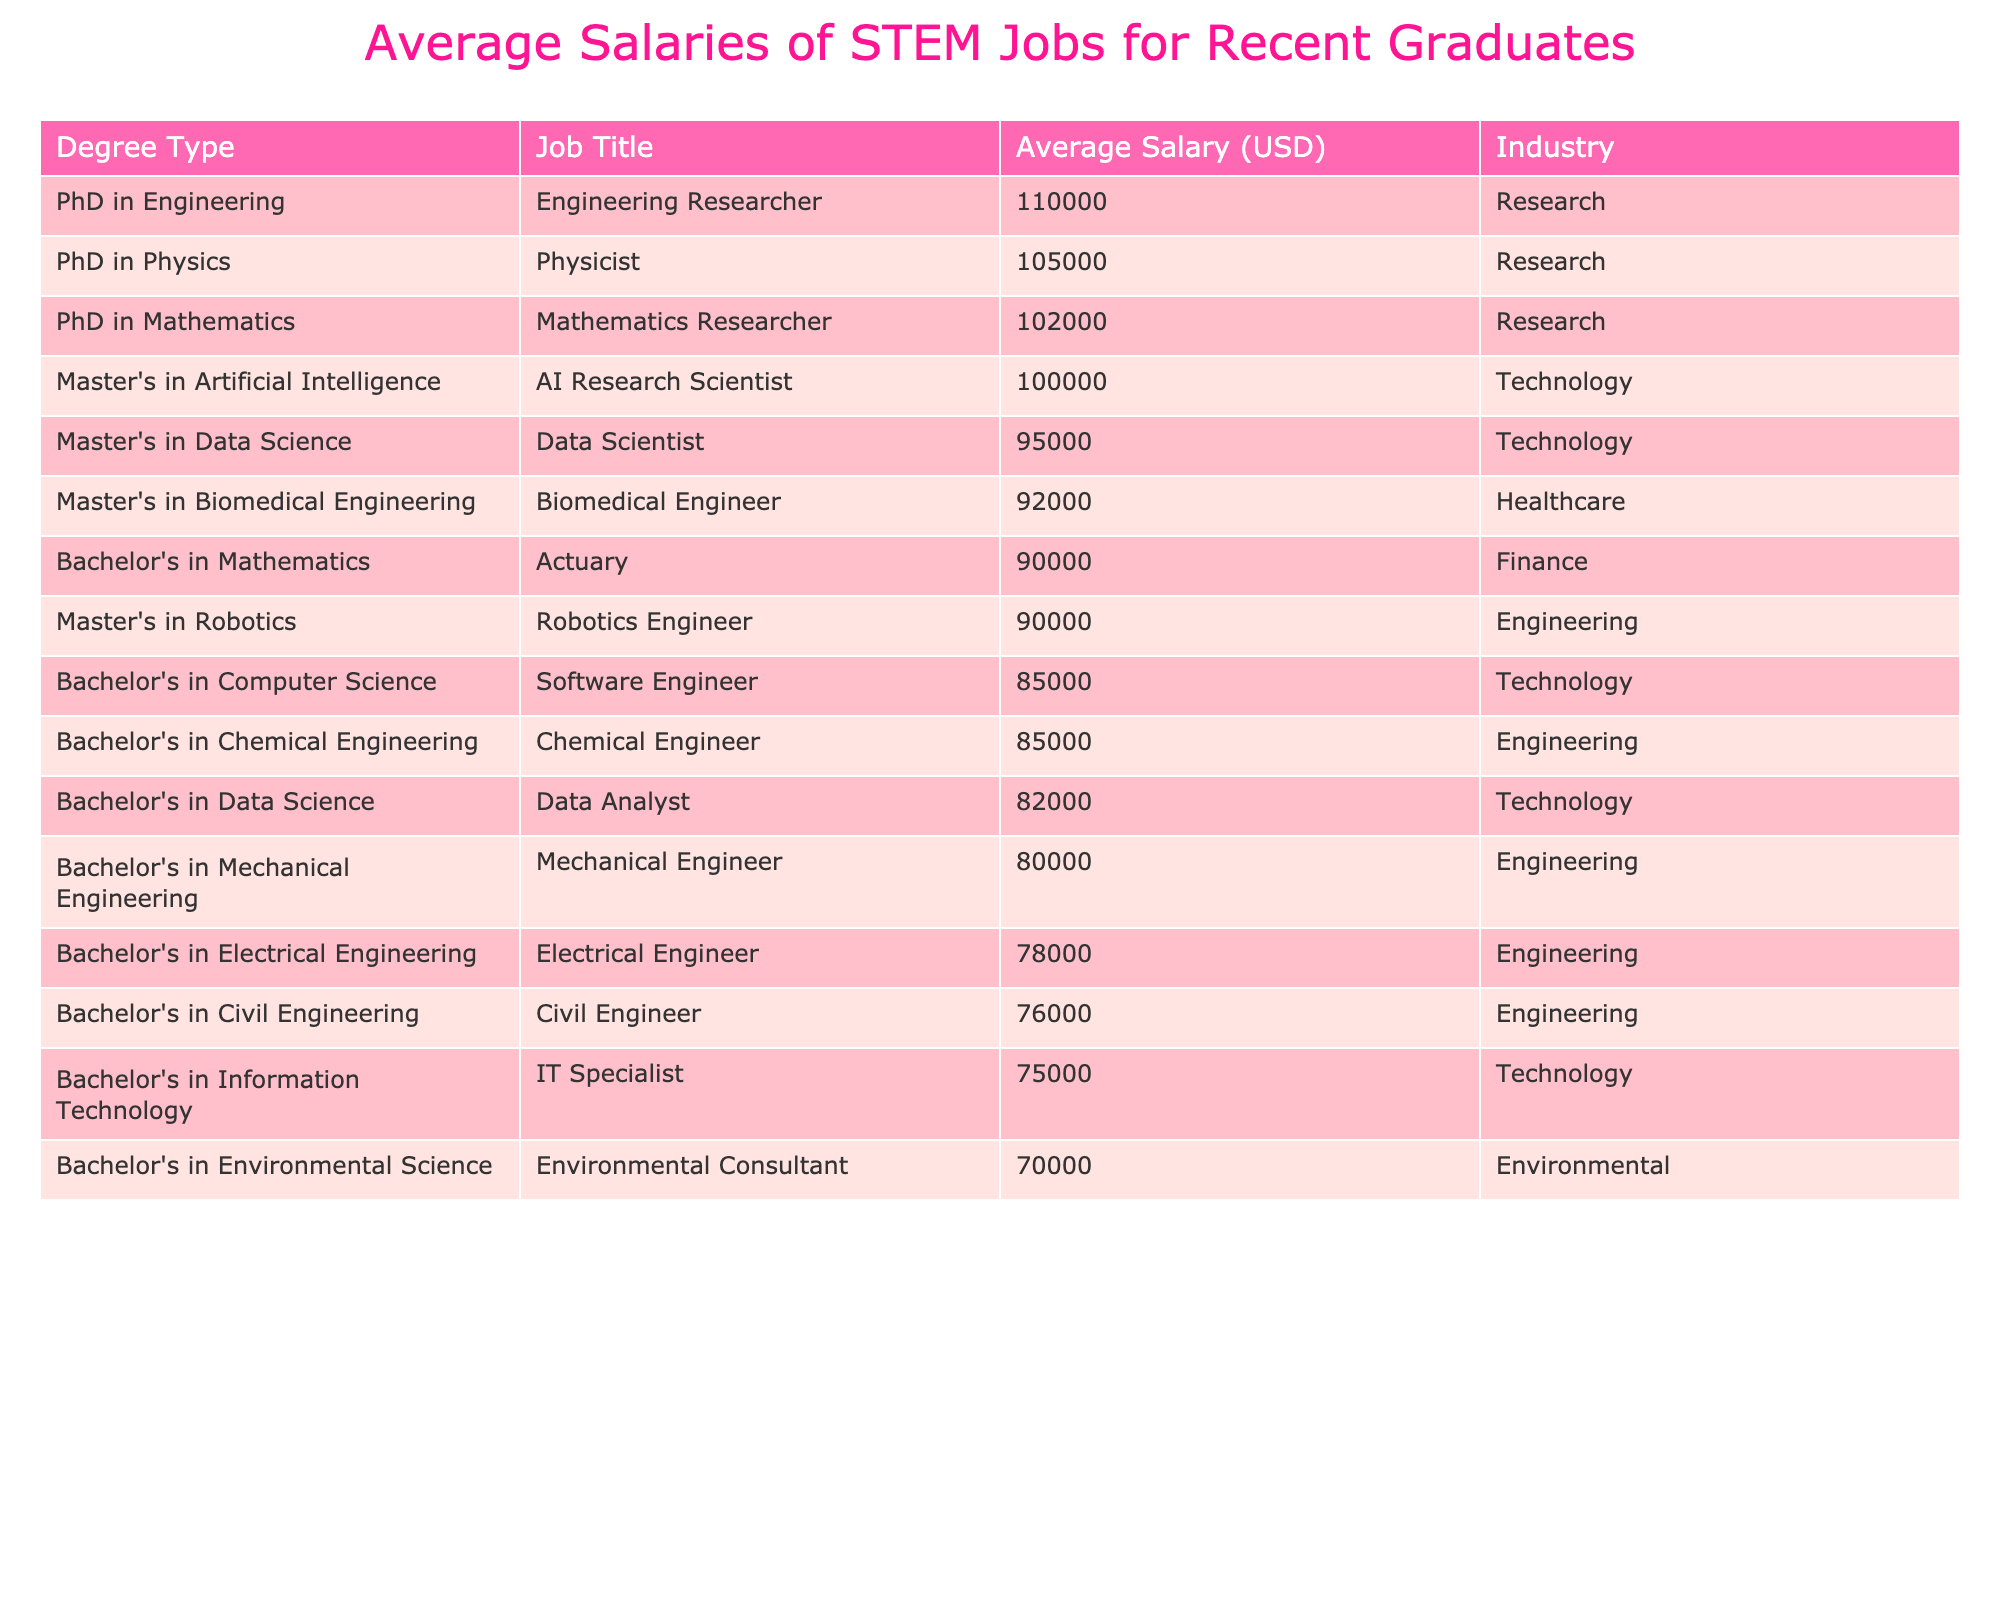What is the average salary of a Software Engineer? The table lists the average salary for the Software Engineer position under the Bachelor's in Computer Science, which is $85,000.
Answer: $85,000 Which job title has the highest average salary? By examining the table, I can see that the job title with the highest average salary is the Engineering Researcher, with an average salary of $110,000.
Answer: Engineering Researcher What is the average salary for jobs related to a Bachelor's degree? To find this, I need to sum the salaries for all Bachelor's degree jobs and divide by the number of jobs. The salaries are $85,000, $78,000, $80,000, $76,000, $82,000, $90,000, $70,000, $85,000, and $75,000. That totals $682,000, and there are 9 bachelor's jobs. Therefore, the average salary is $682,000 / 9 = approximately $75,777.78.
Answer: $75,778 (rounded) Is the average salary of a Master's in Data Science higher than that of a Bachelor's in Computer Science? The average salary for a Master's in Data Science is $95,000, and the average salary for a Bachelor's in Computer Science is $85,000. Since $95,000 is greater than $85,000, the statement is true.
Answer: Yes What is the difference between the average salary of a PhD in Engineering and a Master's in Artificial Intelligence? The average salary for a PhD in Engineering is $110,000, and for a Master's in Artificial Intelligence, it is $100,000. The difference is $110,000 - $100,000 = $10,000.
Answer: $10,000 How many job titles in the table have an average salary of $90,000 or more? I check the table for job titles with average salaries of $90,000 or more. They are: Actuary ($90,000), Biomedical Engineer ($92,000), AI Research Scientist ($100,000), Physicist ($105,000), Mathematics Researcher ($102,000), and Engineering Researcher ($110,000). This totals 6 job titles.
Answer: 6 What is the average salary of jobs in the Engineering industry? The average salaries for Engineering jobs are $78,000 (Electrical Engineer), $80,000 (Mechanical Engineer), $76,000 (Civil Engineer), $85,000 (Chemical Engineer), and $110,000 (Engineering Researcher). The total salary is $429,000 from 5 positions, so the average is $429,000 / 5 = $85,800.
Answer: $85,800 Are there more jobs with an average salary above $85,000 or below $85,000? I analyze the table and find that the following jobs have salaries above $85,000: Software Engineer, Actuary, Biomedical Engineer, AI Research Scientist, Engineering Researcher, Physicist, and Mathematics Researcher, totaling 7 jobs. The following jobs are below $85,000: Electrical Engineer, Mechanical Engineer, Civil Engineer, Environmental Consultant, IT Specialist, and Data Analyst, totaling 6 jobs. Since 7 is greater than 6, there are more jobs above $85,000.
Answer: More jobs above $85,000 What is the salary range for the jobs listed with Bachelor's degrees? The highest salary for a Bachelor's degree is $90,000 for an Actuary, and the lowest is $70,000 for an Environmental Consultant. The range is $90,000 - $70,000 = $20,000.
Answer: $20,000 Which degree type has the highest average salary across multiple job titles? I need to review the average salaries for all job titles under each degree type. The averages are as follows: Bachelor's degrees average about $75,778, Master's degrees average approximately $97,000, and PhDs average $105,333. Since $105,333 is the highest, the PhD degree type has the highest average salary.
Answer: PhD 